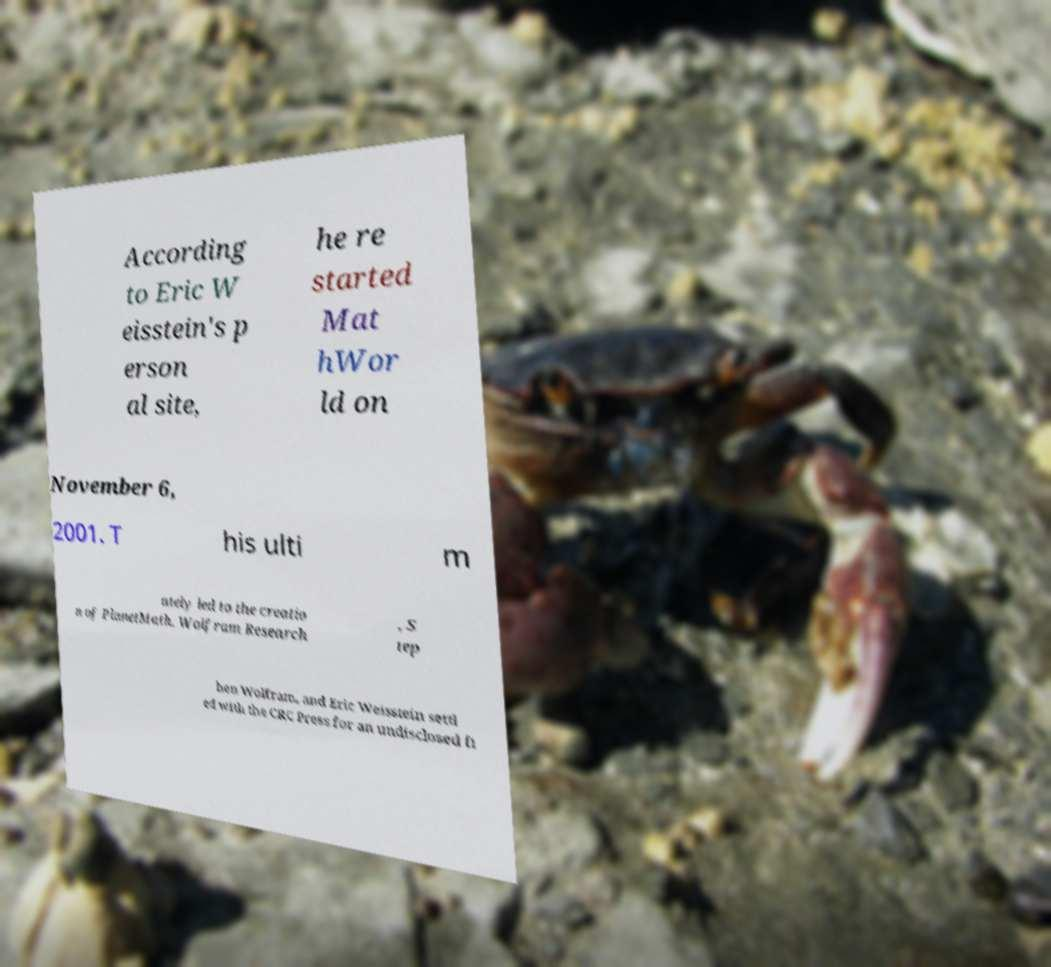Can you read and provide the text displayed in the image?This photo seems to have some interesting text. Can you extract and type it out for me? According to Eric W eisstein's p erson al site, he re started Mat hWor ld on November 6, 2001. T his ulti m ately led to the creatio n of PlanetMath. Wolfram Research , S tep hen Wolfram, and Eric Weisstein settl ed with the CRC Press for an undisclosed fi 